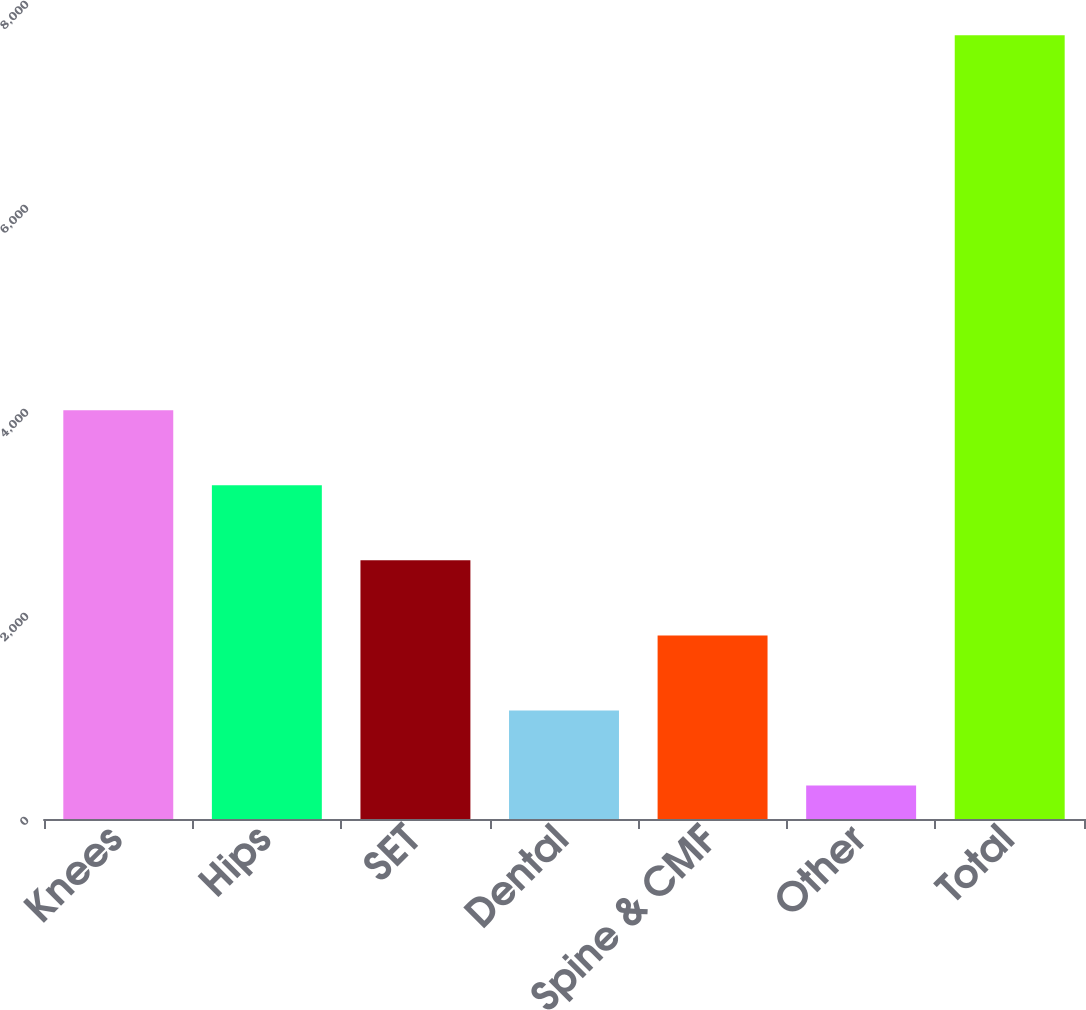Convert chart. <chart><loc_0><loc_0><loc_500><loc_500><bar_chart><fcel>Knees<fcel>Hips<fcel>SET<fcel>Dental<fcel>Spine & CMF<fcel>Other<fcel>Total<nl><fcel>4006.5<fcel>3271.02<fcel>2535.54<fcel>1064.58<fcel>1800.06<fcel>329.1<fcel>7683.9<nl></chart> 